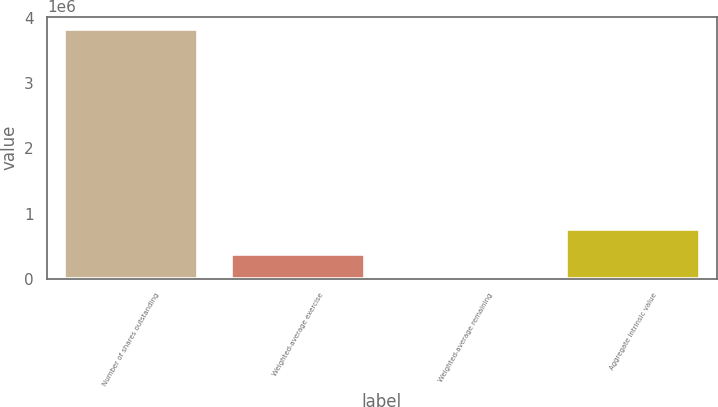Convert chart. <chart><loc_0><loc_0><loc_500><loc_500><bar_chart><fcel>Number of shares outstanding<fcel>Weighted-average exercise<fcel>Weighted-average remaining<fcel>Aggregate intrinsic value<nl><fcel>3.82482e+06<fcel>382488<fcel>6.34<fcel>764969<nl></chart> 